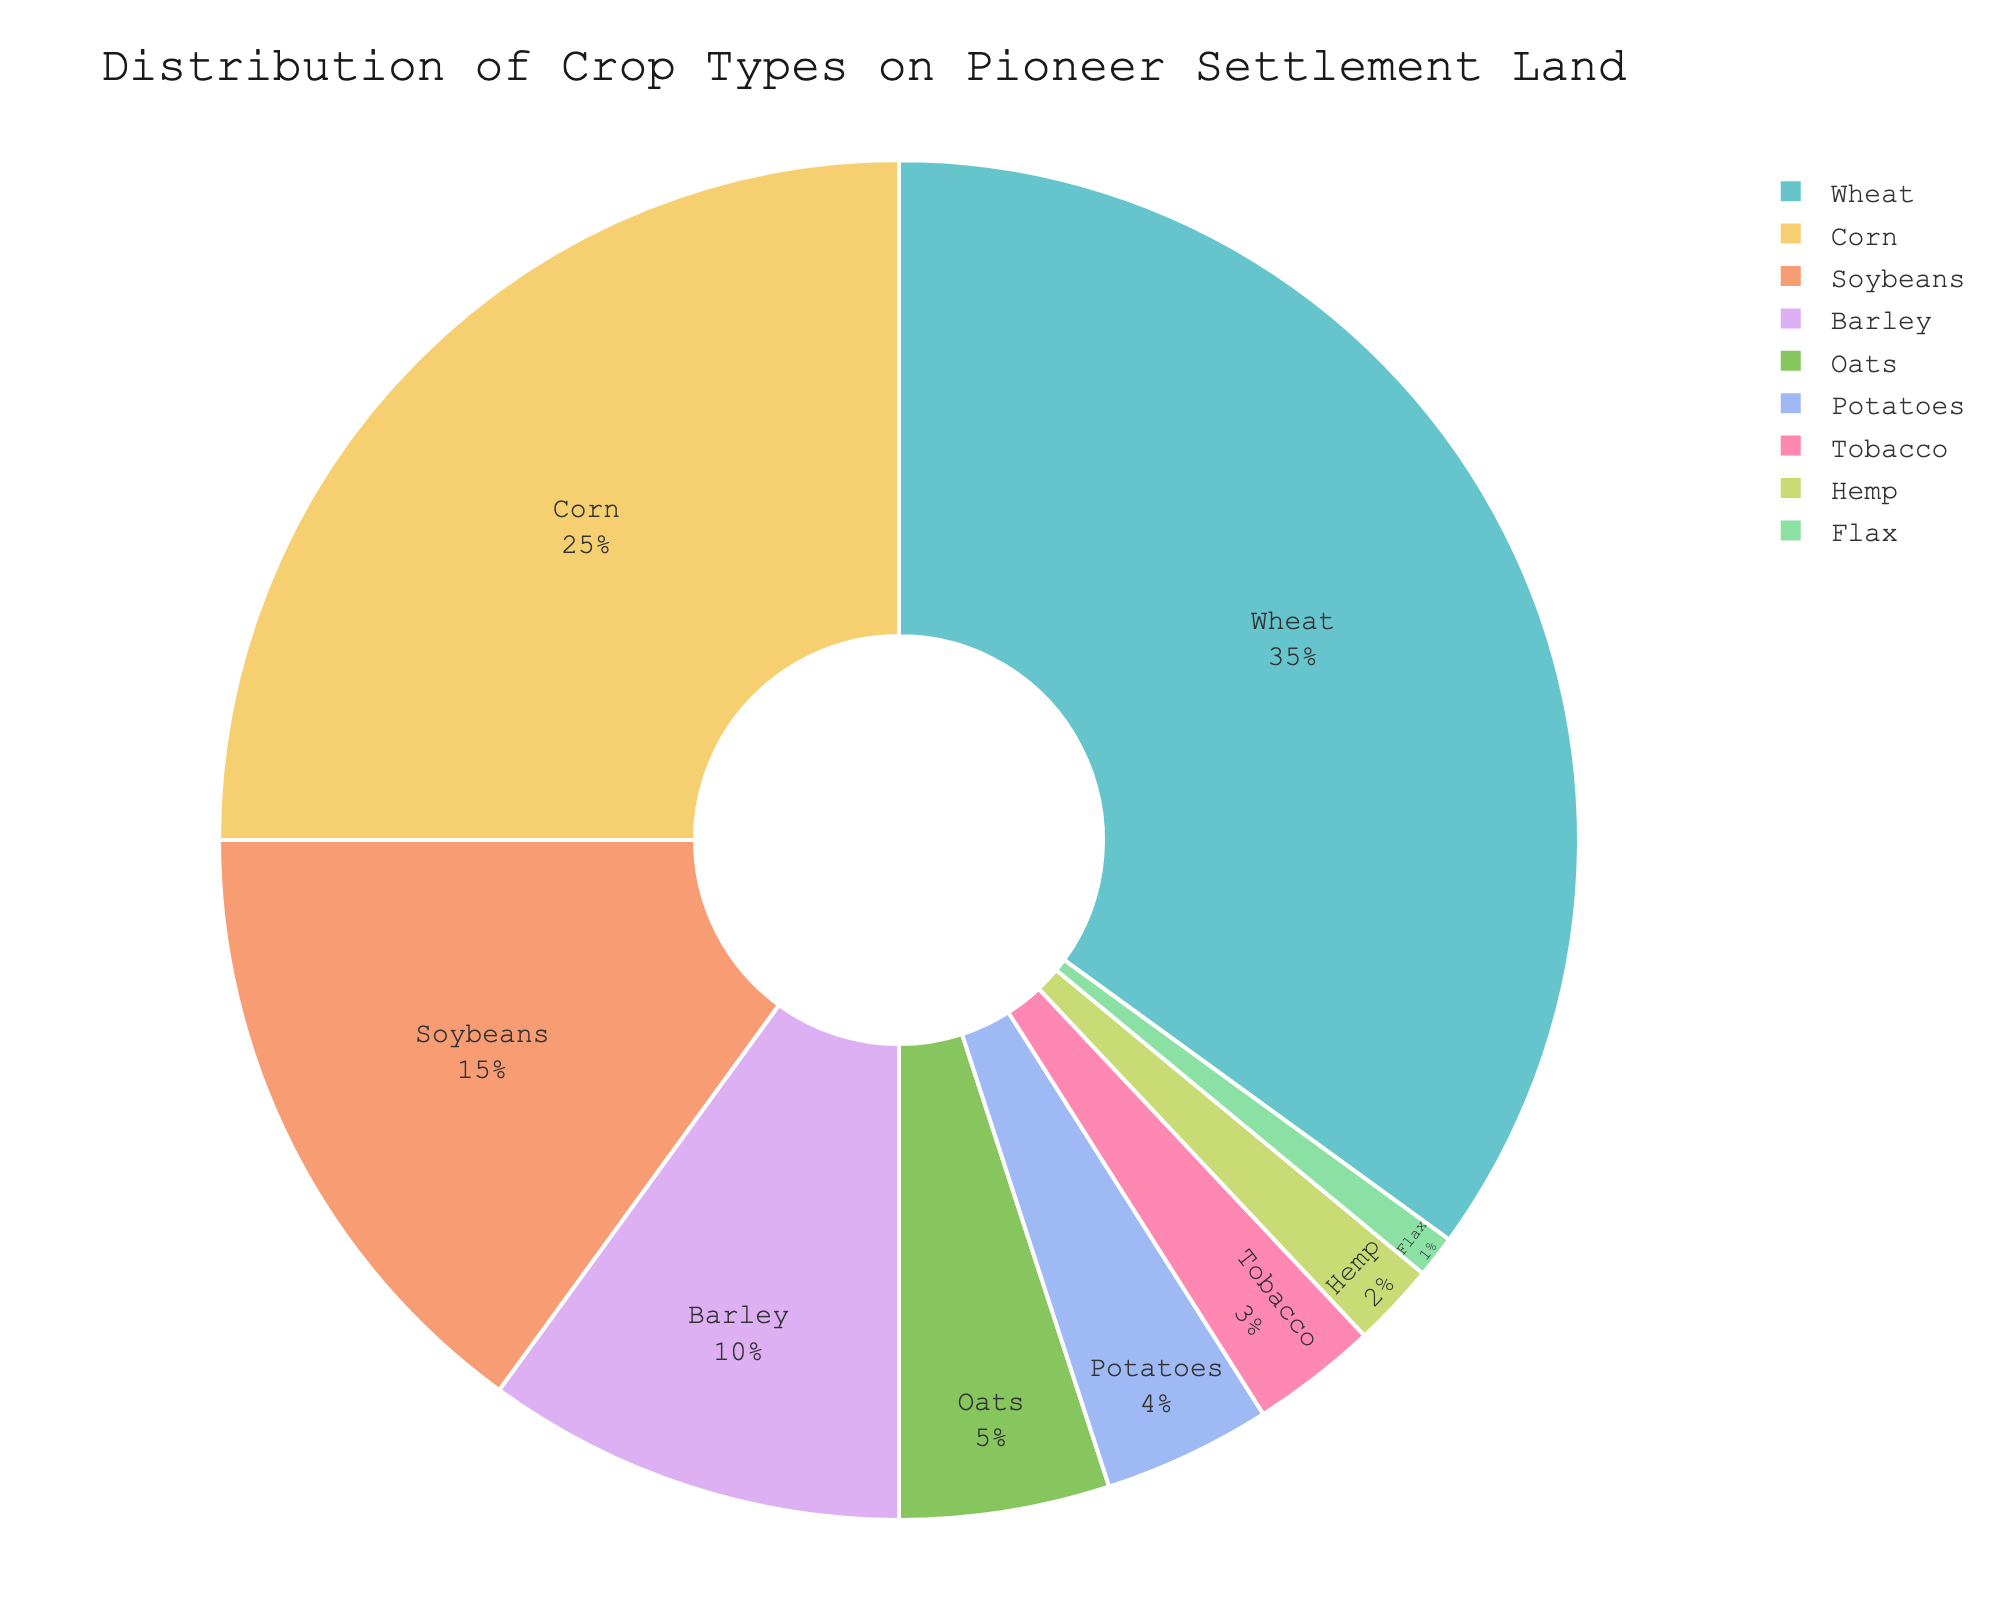What's the largest crop type grown on the pioneer settlement land? By observing the pie chart, the slice corresponding to the largest crop type is labeled 'Wheat' with a percentage of 35%.
Answer: Wheat Which crop type has the smallest share on the pioneer settlement land? The pie chart shows that 'Flax' has the smallest slice, labeled with a percentage of 1%.
Answer: Flax How much more percentage of land is used to grow Wheat than Corn? Wheat has 35% while Corn has 25%. The difference is calculated as 35% - 25% = 10%.
Answer: 10% Do Barley and Oats together make up more or less than 20%? Barley is 10% and Oats is 5%. Together, they sum up to 10% + 5% = 15%, which is less than 20%.
Answer: Less What is the combined percentage of Soybeans, Barley, and Oats? Soybeans have 15%, Barley has 10%, and Oats have 5%. The combined percentage is 15% + 10% + 5% = 30%.
Answer: 30% Which crop type has a larger share, Tobacco or Potatoes? By visually comparing their slices, Potatoes have 4% while Tobacco has 3%. Hence, Potatoes have a larger share.
Answer: Potatoes Are the percentages of Corn and Soybeans together greater than the percentage of Wheat? Corn is 25% and Soybeans is 15%. Together, they make 25% + 15% = 40%, which is greater than Wheat's 35%.
Answer: Yes Which of the crop types have a percentage represented by a two-digit number? By observing the pie chart, Wheat (35%), Corn (25%), Soybeans (15%), and Barley (10%) have two-digit percentages.
Answer: Wheat, Corn, Soybeans, Barley What's the percentage difference between Potatoes and Oats? Potatoes have 4% and Oats have 5%. The difference is calculated as 5% - 4% = 1%.
Answer: 1% What is the total percentage of land used for growing Tobacco, Hemp, and Flax? Tobacco is 3%, Hemp is 2%, and Flax is 1%. The total is calculated as 3% + 2% + 1% = 6%.
Answer: 6% 